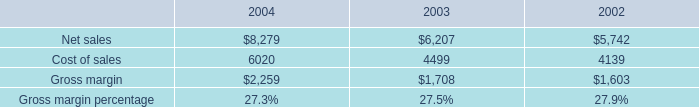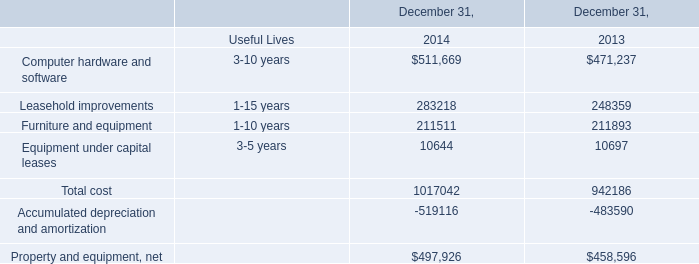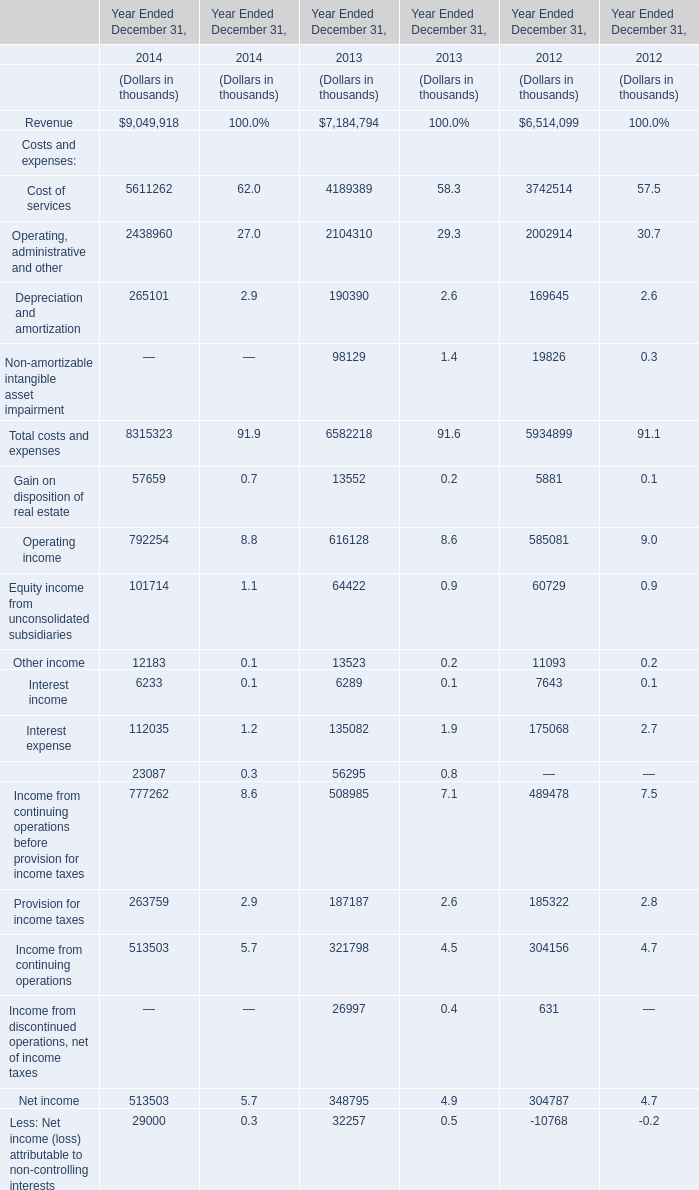In the year with largest amount of Total costs and expenses, what's the increasing rate of Cost of services? 
Computations: ((5611262 - 4189389) / 4189389)
Answer: 0.3394. 